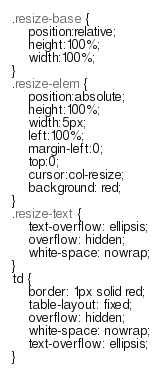Convert code to text. <code><loc_0><loc_0><loc_500><loc_500><_CSS_>.resize-base {
    position:relative;
    height:100%;
    width:100%;
}
.resize-elem {
    position:absolute;
    height:100%;
    width:5px;
    left:100%;
    margin-left:0;
    top:0;
    cursor:col-resize;
    background: red;
}
.resize-text {
    text-overflow: ellipsis;
    overflow: hidden;
    white-space: nowrap;
}
td {
    border: 1px solid red;
    table-layout: fixed;
    overflow: hidden;
    white-space: nowrap;
    text-overflow: ellipsis;
}</code> 